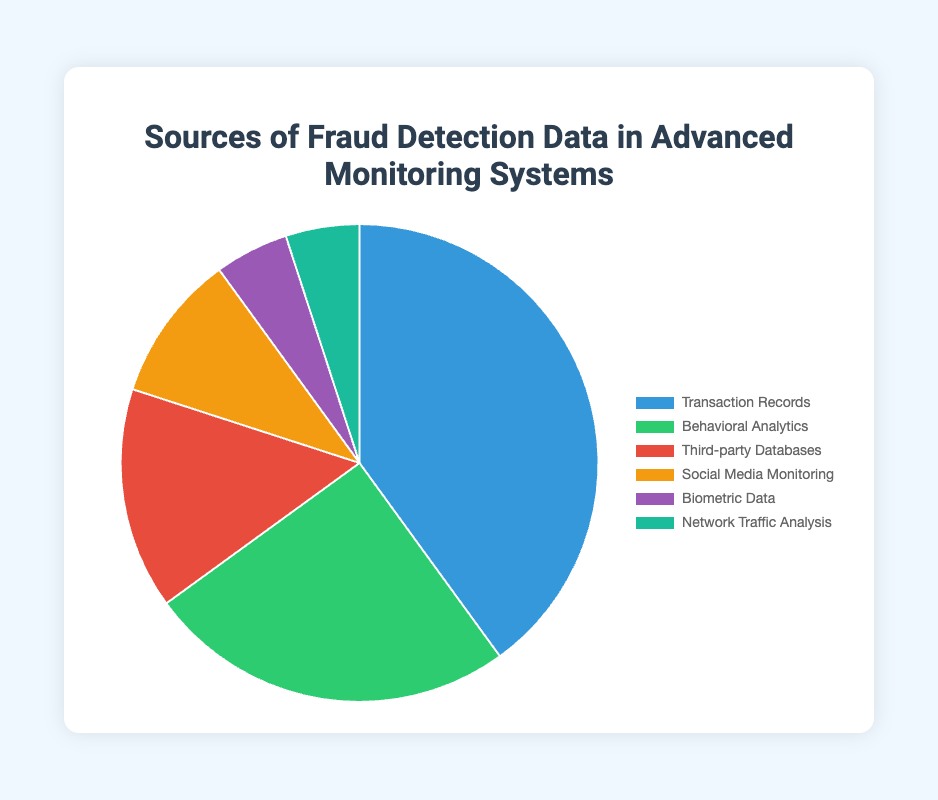What is the most utilized source of fraud detection data? The source with the highest percentage in the pie chart represents the most utilized data source. The largest segment is labeled "Transaction Records," which accounts for 40%.
Answer: Transaction Records Which data sources are tied with the smallest percentage? To determine this, look for the segments with the smallest and equal percentages. Both "Biometric Data" and "Network Traffic Analysis" are labeled with 5%.
Answer: Biometric Data and Network Traffic Analysis What is the combined percentage of Behavioral Analytics and Third-party Databases? Add the percentages of Behavioral Analytics (25%) and Third-party Databases (15%). 25% + 15% = 40%
Answer: 40% How much more is the percentage of Transaction Records compared to Social Media Monitoring? Subtract the percentage of Social Media Monitoring (10%) from that of Transaction Records (40%). 40% - 10% = 30%
Answer: 30% Which category has a larger percentage, Biometric Data or Network Traffic Analysis, and by how much? Since Biometric Data and Network Traffic Analysis both have the same percentage (5%), neither is larger.
Answer: Neither; 0% Which segment is visually represented by the color green? Refer to the pie chart's color legend. The green segment corresponds to "Behavioral Analytics."
Answer: Behavioral Analytics What is the total percentage for all the sources excluding Transaction Records and Behavioral Analytics? Subtract the sum of Transaction Records (40%) and Behavioral Analytics (25%) from 100%. 100% - (40% + 25%) = 35%
Answer: 35% If we combine Social Media Monitoring, Biometric Data, and Network Traffic Analysis, do they sum up to more than Behavioral Analytics? Add the percentages of Social Media Monitoring (10%), Biometric Data (5%), and Network Traffic Analysis (5%). Compare their sum to Behavioral Analytics (25%). 10% + 5% + 5% = 20%; 20% is less than 25%.
Answer: No What is the average percentage of all the data sources? Divide the sum of all percentages (100%) by the number of sources (6). 100% / 6 ≈ 16.67%
Answer: 16.67% If Biometric Data increased by 10%, what would its new percentage be? Add 10% to the original Biometric Data percentage (5%). 5% + 10% = 15%
Answer: 15% 